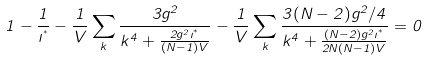Convert formula to latex. <formula><loc_0><loc_0><loc_500><loc_500>1 - \frac { 1 } { \zeta ^ { ^ { * } } } - \frac { 1 } { V } \sum _ { k } \frac { 3 g ^ { 2 } } { k ^ { 4 } + \frac { 2 g ^ { 2 } \zeta ^ { ^ { * } } } { ( N - 1 ) V } } - \frac { 1 } { V } \sum _ { k } \frac { 3 ( N - 2 ) g ^ { 2 } / 4 } { k ^ { 4 } + \frac { ( N - 2 ) g ^ { 2 } \zeta ^ { ^ { * } } } { 2 N ( N - 1 ) V } } = 0</formula> 